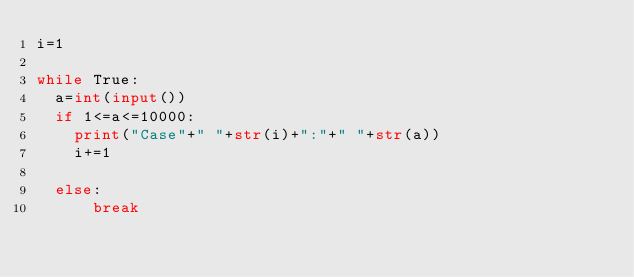Convert code to text. <code><loc_0><loc_0><loc_500><loc_500><_Python_>i=1

while True:
  a=int(input())
  if 1<=a<=10000:
    print("Case"+" "+str(i)+":"+" "+str(a))
    i+=1

  else:
      break
    
  </code> 